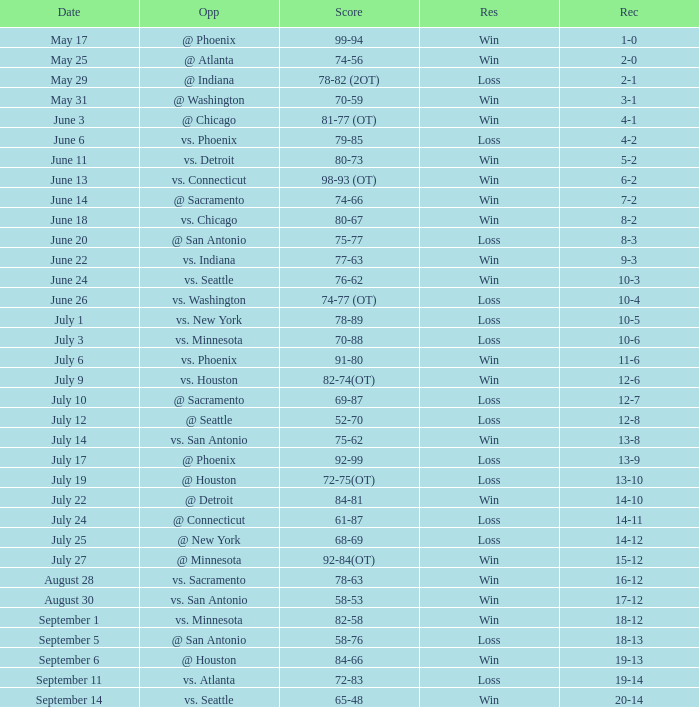What is the Score of the game @ San Antonio on June 20? 75-77. 